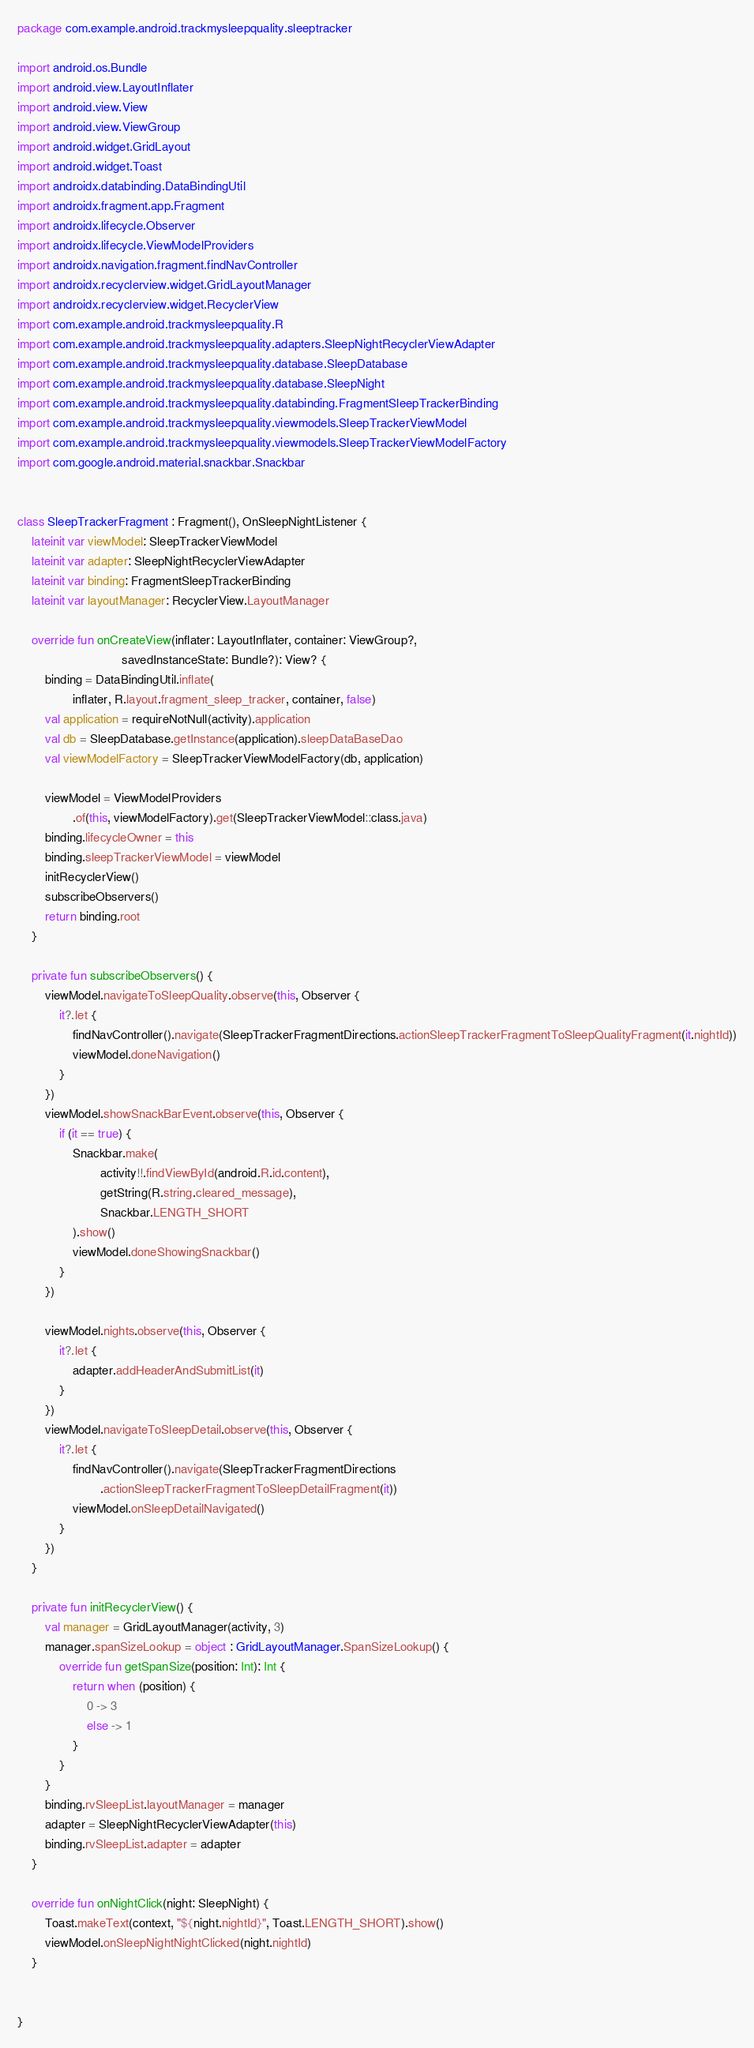Convert code to text. <code><loc_0><loc_0><loc_500><loc_500><_Kotlin_>package com.example.android.trackmysleepquality.sleeptracker

import android.os.Bundle
import android.view.LayoutInflater
import android.view.View
import android.view.ViewGroup
import android.widget.GridLayout
import android.widget.Toast
import androidx.databinding.DataBindingUtil
import androidx.fragment.app.Fragment
import androidx.lifecycle.Observer
import androidx.lifecycle.ViewModelProviders
import androidx.navigation.fragment.findNavController
import androidx.recyclerview.widget.GridLayoutManager
import androidx.recyclerview.widget.RecyclerView
import com.example.android.trackmysleepquality.R
import com.example.android.trackmysleepquality.adapters.SleepNightRecyclerViewAdapter
import com.example.android.trackmysleepquality.database.SleepDatabase
import com.example.android.trackmysleepquality.database.SleepNight
import com.example.android.trackmysleepquality.databinding.FragmentSleepTrackerBinding
import com.example.android.trackmysleepquality.viewmodels.SleepTrackerViewModel
import com.example.android.trackmysleepquality.viewmodels.SleepTrackerViewModelFactory
import com.google.android.material.snackbar.Snackbar


class SleepTrackerFragment : Fragment(), OnSleepNightListener {
    lateinit var viewModel: SleepTrackerViewModel
    lateinit var adapter: SleepNightRecyclerViewAdapter
    lateinit var binding: FragmentSleepTrackerBinding
    lateinit var layoutManager: RecyclerView.LayoutManager

    override fun onCreateView(inflater: LayoutInflater, container: ViewGroup?,
                              savedInstanceState: Bundle?): View? {
        binding = DataBindingUtil.inflate(
                inflater, R.layout.fragment_sleep_tracker, container, false)
        val application = requireNotNull(activity).application
        val db = SleepDatabase.getInstance(application).sleepDataBaseDao
        val viewModelFactory = SleepTrackerViewModelFactory(db, application)

        viewModel = ViewModelProviders
                .of(this, viewModelFactory).get(SleepTrackerViewModel::class.java)
        binding.lifecycleOwner = this
        binding.sleepTrackerViewModel = viewModel
        initRecyclerView()
        subscribeObservers()
        return binding.root
    }

    private fun subscribeObservers() {
        viewModel.navigateToSleepQuality.observe(this, Observer {
            it?.let {
                findNavController().navigate(SleepTrackerFragmentDirections.actionSleepTrackerFragmentToSleepQualityFragment(it.nightId))
                viewModel.doneNavigation()
            }
        })
        viewModel.showSnackBarEvent.observe(this, Observer {
            if (it == true) {
                Snackbar.make(
                        activity!!.findViewById(android.R.id.content),
                        getString(R.string.cleared_message),
                        Snackbar.LENGTH_SHORT
                ).show()
                viewModel.doneShowingSnackbar()
            }
        })

        viewModel.nights.observe(this, Observer {
            it?.let {
                adapter.addHeaderAndSubmitList(it)
            }
        })
        viewModel.navigateToSleepDetail.observe(this, Observer {
            it?.let {
                findNavController().navigate(SleepTrackerFragmentDirections
                        .actionSleepTrackerFragmentToSleepDetailFragment(it))
                viewModel.onSleepDetailNavigated()
            }
        })
    }

    private fun initRecyclerView() {
        val manager = GridLayoutManager(activity, 3)
        manager.spanSizeLookup = object : GridLayoutManager.SpanSizeLookup() {
            override fun getSpanSize(position: Int): Int {
                return when (position) {
                    0 -> 3
                    else -> 1
                }
            }
        }
        binding.rvSleepList.layoutManager = manager
        adapter = SleepNightRecyclerViewAdapter(this)
        binding.rvSleepList.adapter = adapter
    }

    override fun onNightClick(night: SleepNight) {
        Toast.makeText(context, "${night.nightId}", Toast.LENGTH_SHORT).show()
        viewModel.onSleepNightNightClicked(night.nightId)
    }


}

</code> 